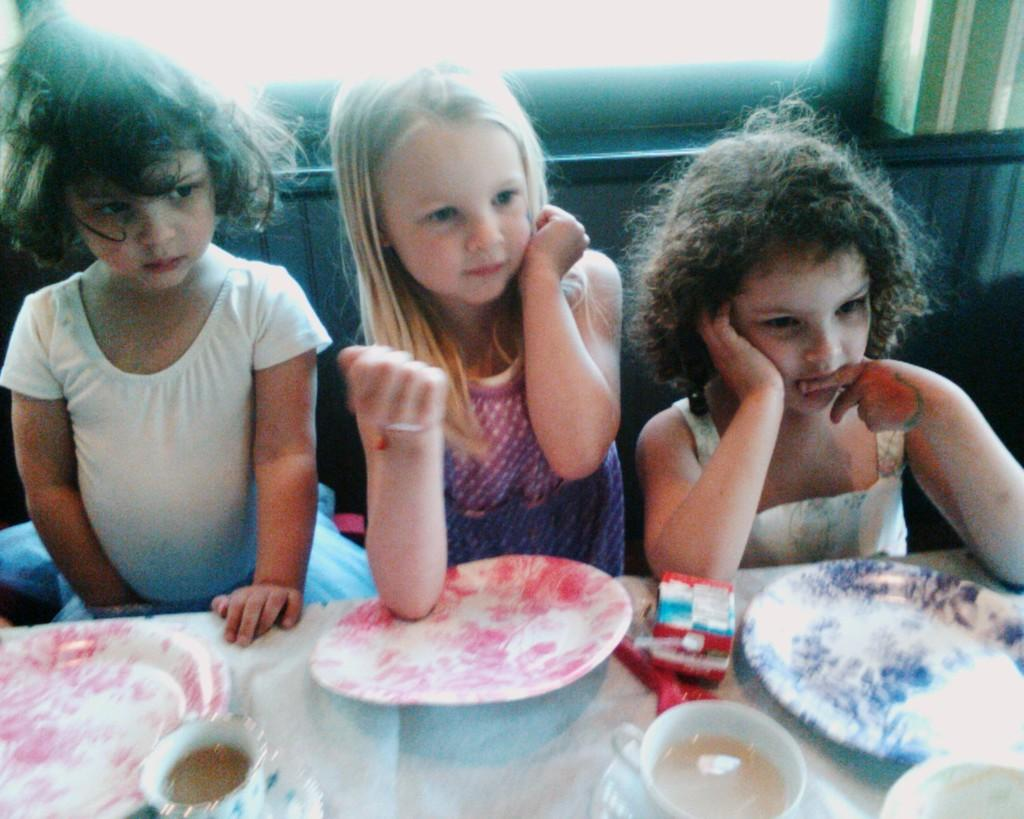How many girls are in the image? There are three little girls in the image. Where are the girls sitting? The girls are sitting in front of a dining table. What items can be seen on the table? There are plates, spoons, a cup, and a saucer on the table. What is visible on the wall behind the girls? There is a window on the wall behind the girls. What is the profit margin of the girls' business in the image? There is no indication of a business or profit margin in the image; it simply shows three little girls sitting in front of a dining table. 